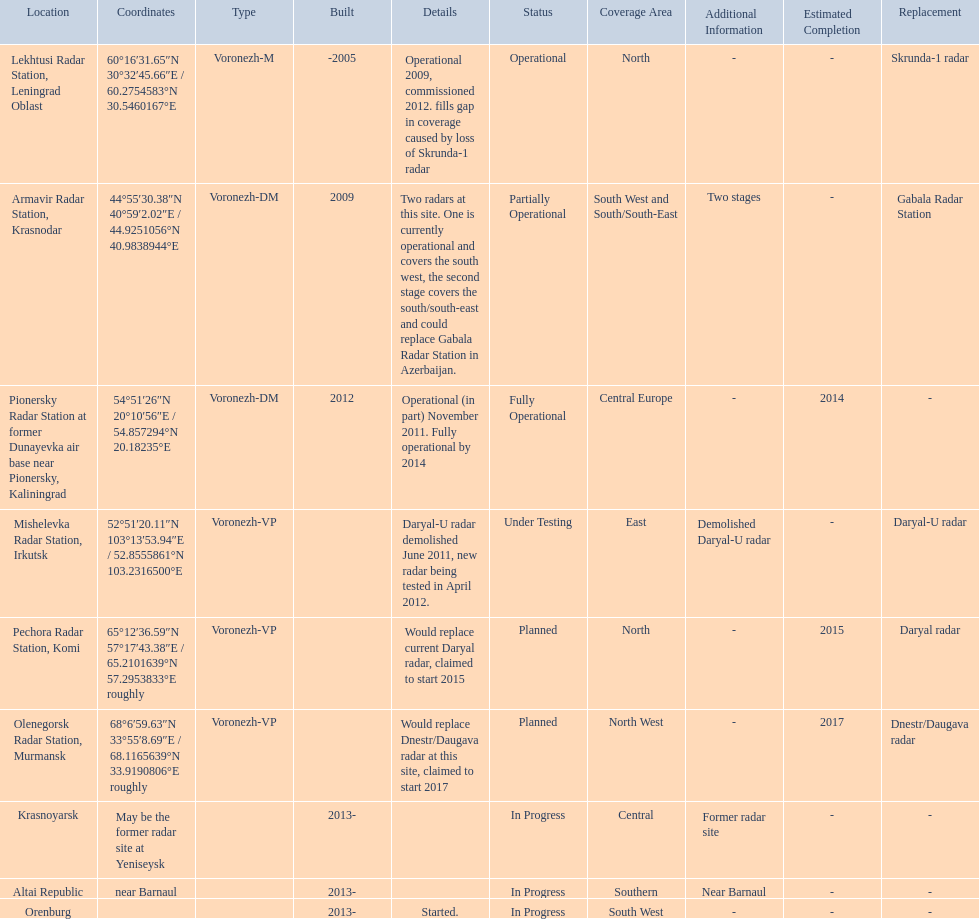Which voronezh radar has already started? Orenburg. Which radar would replace dnestr/daugava? Olenegorsk Radar Station, Murmansk. Which radar started in 2015? Pechora Radar Station, Komi. 